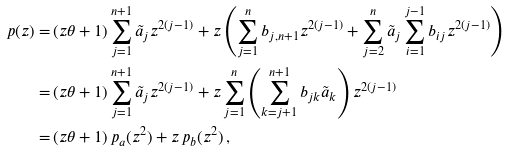<formula> <loc_0><loc_0><loc_500><loc_500>p ( z ) = & \left ( z \theta + 1 \right ) \sum _ { j = 1 } ^ { n + 1 } \tilde { a } _ { j } z ^ { 2 ( j - 1 ) } + z \left ( \sum _ { j = 1 } ^ { n } b _ { j , n + 1 } z ^ { 2 ( j - 1 ) } + \sum _ { j = 2 } ^ { n } \tilde { a } _ { j } \sum _ { i = 1 } ^ { j - 1 } b _ { i j } z ^ { 2 ( j - 1 ) } \right ) \\ = & \left ( z \theta + 1 \right ) \sum _ { j = 1 } ^ { n + 1 } \tilde { a } _ { j } z ^ { 2 ( j - 1 ) } + z \sum _ { j = 1 } ^ { n } \left ( \sum _ { k = j + 1 } ^ { n + 1 } b _ { j k } \tilde { a } _ { k } \right ) z ^ { 2 ( j - 1 ) } \\ = & \left ( z \theta + 1 \right ) p _ { a } ( z ^ { 2 } ) + z \, p _ { b } ( z ^ { 2 } ) \, ,</formula> 